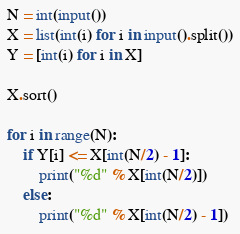<code> <loc_0><loc_0><loc_500><loc_500><_Python_>N = int(input())
X = list(int(i) for i in input().split())
Y = [int(i) for i in X]

X.sort()

for i in range(N):
    if Y[i] <= X[int(N/2) - 1]:
        print("%d" % X[int(N/2)])
    else:
        print("%d" % X[int(N/2) - 1])</code> 